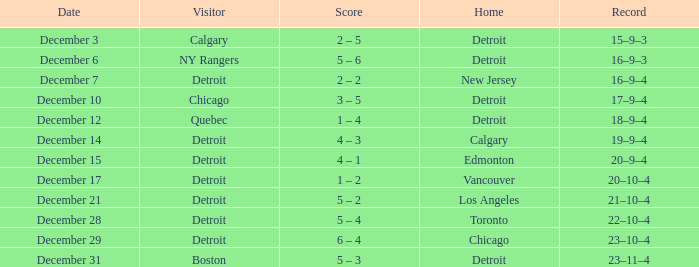Would you be able to parse every entry in this table? {'header': ['Date', 'Visitor', 'Score', 'Home', 'Record'], 'rows': [['December 3', 'Calgary', '2 – 5', 'Detroit', '15–9–3'], ['December 6', 'NY Rangers', '5 – 6', 'Detroit', '16–9–3'], ['December 7', 'Detroit', '2 – 2', 'New Jersey', '16–9–4'], ['December 10', 'Chicago', '3 – 5', 'Detroit', '17–9–4'], ['December 12', 'Quebec', '1 – 4', 'Detroit', '18–9–4'], ['December 14', 'Detroit', '4 – 3', 'Calgary', '19–9–4'], ['December 15', 'Detroit', '4 – 1', 'Edmonton', '20–9–4'], ['December 17', 'Detroit', '1 – 2', 'Vancouver', '20–10–4'], ['December 21', 'Detroit', '5 – 2', 'Los Angeles', '21–10–4'], ['December 28', 'Detroit', '5 – 4', 'Toronto', '22–10–4'], ['December 29', 'Detroit', '6 – 4', 'Chicago', '23–10–4'], ['December 31', 'Boston', '5 – 3', 'Detroit', '23–11–4']]} What is the score on december 10? 3 – 5. 